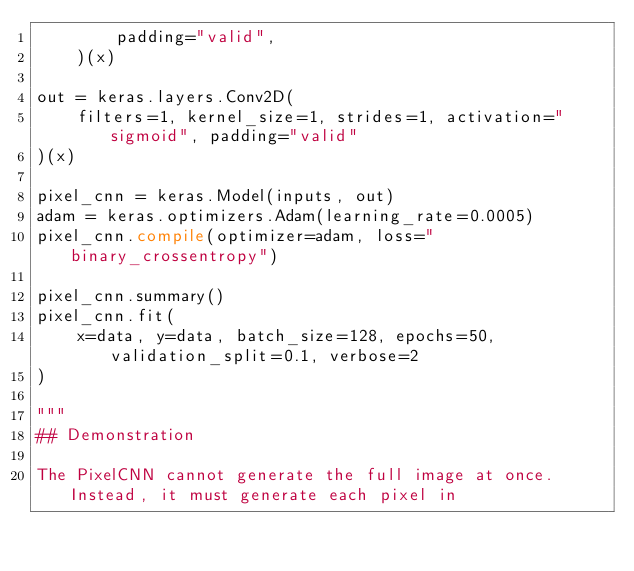Convert code to text. <code><loc_0><loc_0><loc_500><loc_500><_Python_>        padding="valid",
    )(x)

out = keras.layers.Conv2D(
    filters=1, kernel_size=1, strides=1, activation="sigmoid", padding="valid"
)(x)

pixel_cnn = keras.Model(inputs, out)
adam = keras.optimizers.Adam(learning_rate=0.0005)
pixel_cnn.compile(optimizer=adam, loss="binary_crossentropy")

pixel_cnn.summary()
pixel_cnn.fit(
    x=data, y=data, batch_size=128, epochs=50, validation_split=0.1, verbose=2
)

"""
## Demonstration

The PixelCNN cannot generate the full image at once. Instead, it must generate each pixel in</code> 